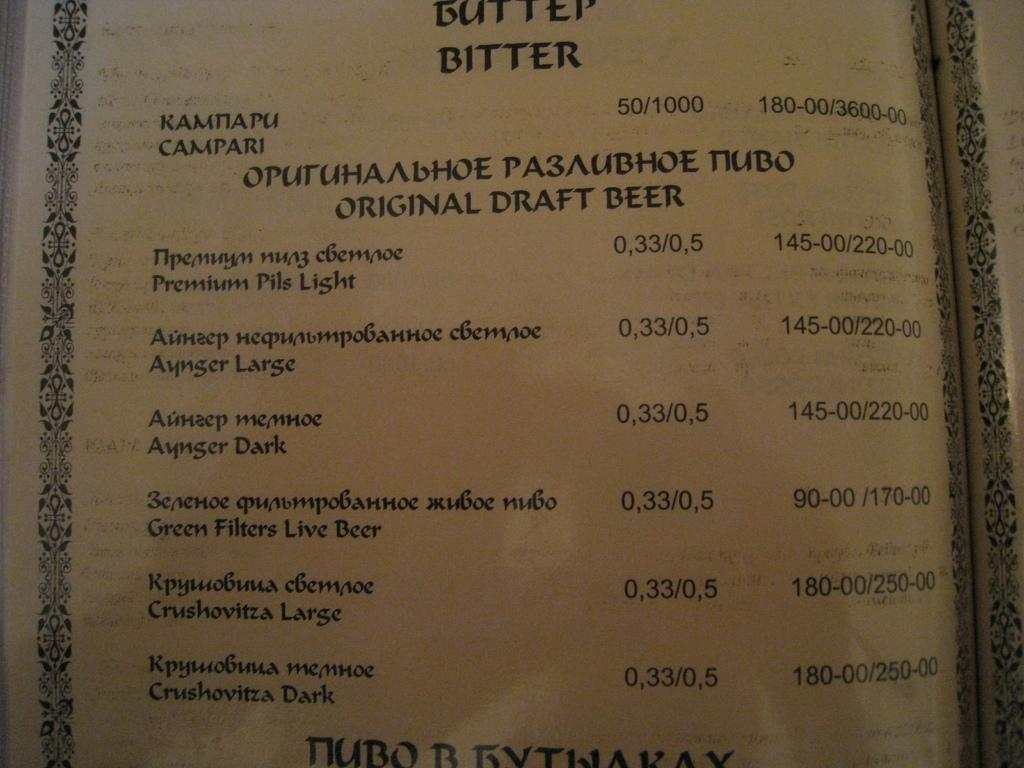<image>
Present a compact description of the photo's key features. A menu in greek has english writing listing Original Draft Beers. 